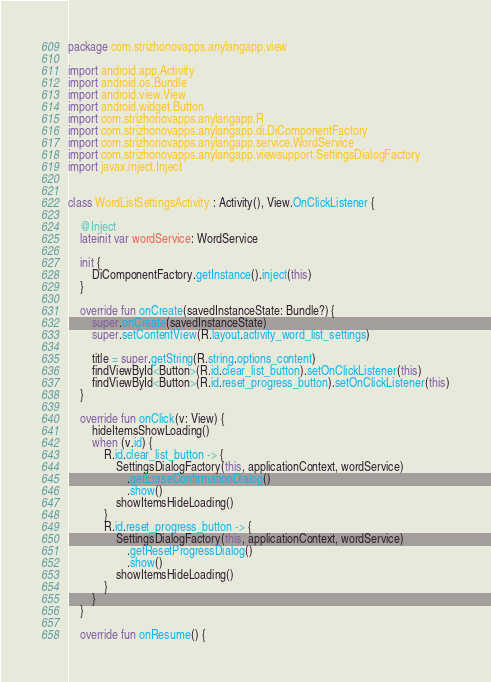Convert code to text. <code><loc_0><loc_0><loc_500><loc_500><_Kotlin_>package com.strizhonovapps.anylangapp.view

import android.app.Activity
import android.os.Bundle
import android.view.View
import android.widget.Button
import com.strizhonovapps.anylangapp.R
import com.strizhonovapps.anylangapp.di.DiComponentFactory
import com.strizhonovapps.anylangapp.service.WordService
import com.strizhonovapps.anylangapp.viewsupport.SettingsDialogFactory
import javax.inject.Inject


class WordListSettingsActivity : Activity(), View.OnClickListener {

    @Inject
    lateinit var wordService: WordService

    init {
        DiComponentFactory.getInstance().inject(this)
    }

    override fun onCreate(savedInstanceState: Bundle?) {
        super.onCreate(savedInstanceState)
        super.setContentView(R.layout.activity_word_list_settings)

        title = super.getString(R.string.options_content)
        findViewById<Button>(R.id.clear_list_button).setOnClickListener(this)
        findViewById<Button>(R.id.reset_progress_button).setOnClickListener(this)
    }

    override fun onClick(v: View) {
        hideItemsShowLoading()
        when (v.id) {
            R.id.clear_list_button -> {
                SettingsDialogFactory(this, applicationContext, wordService)
                    .getEraseConfirmationDialog()
                    .show()
                showItemsHideLoading()
            }
            R.id.reset_progress_button -> {
                SettingsDialogFactory(this, applicationContext, wordService)
                    .getResetProgressDialog()
                    .show()
                showItemsHideLoading()
            }
        }
    }

    override fun onResume() {</code> 